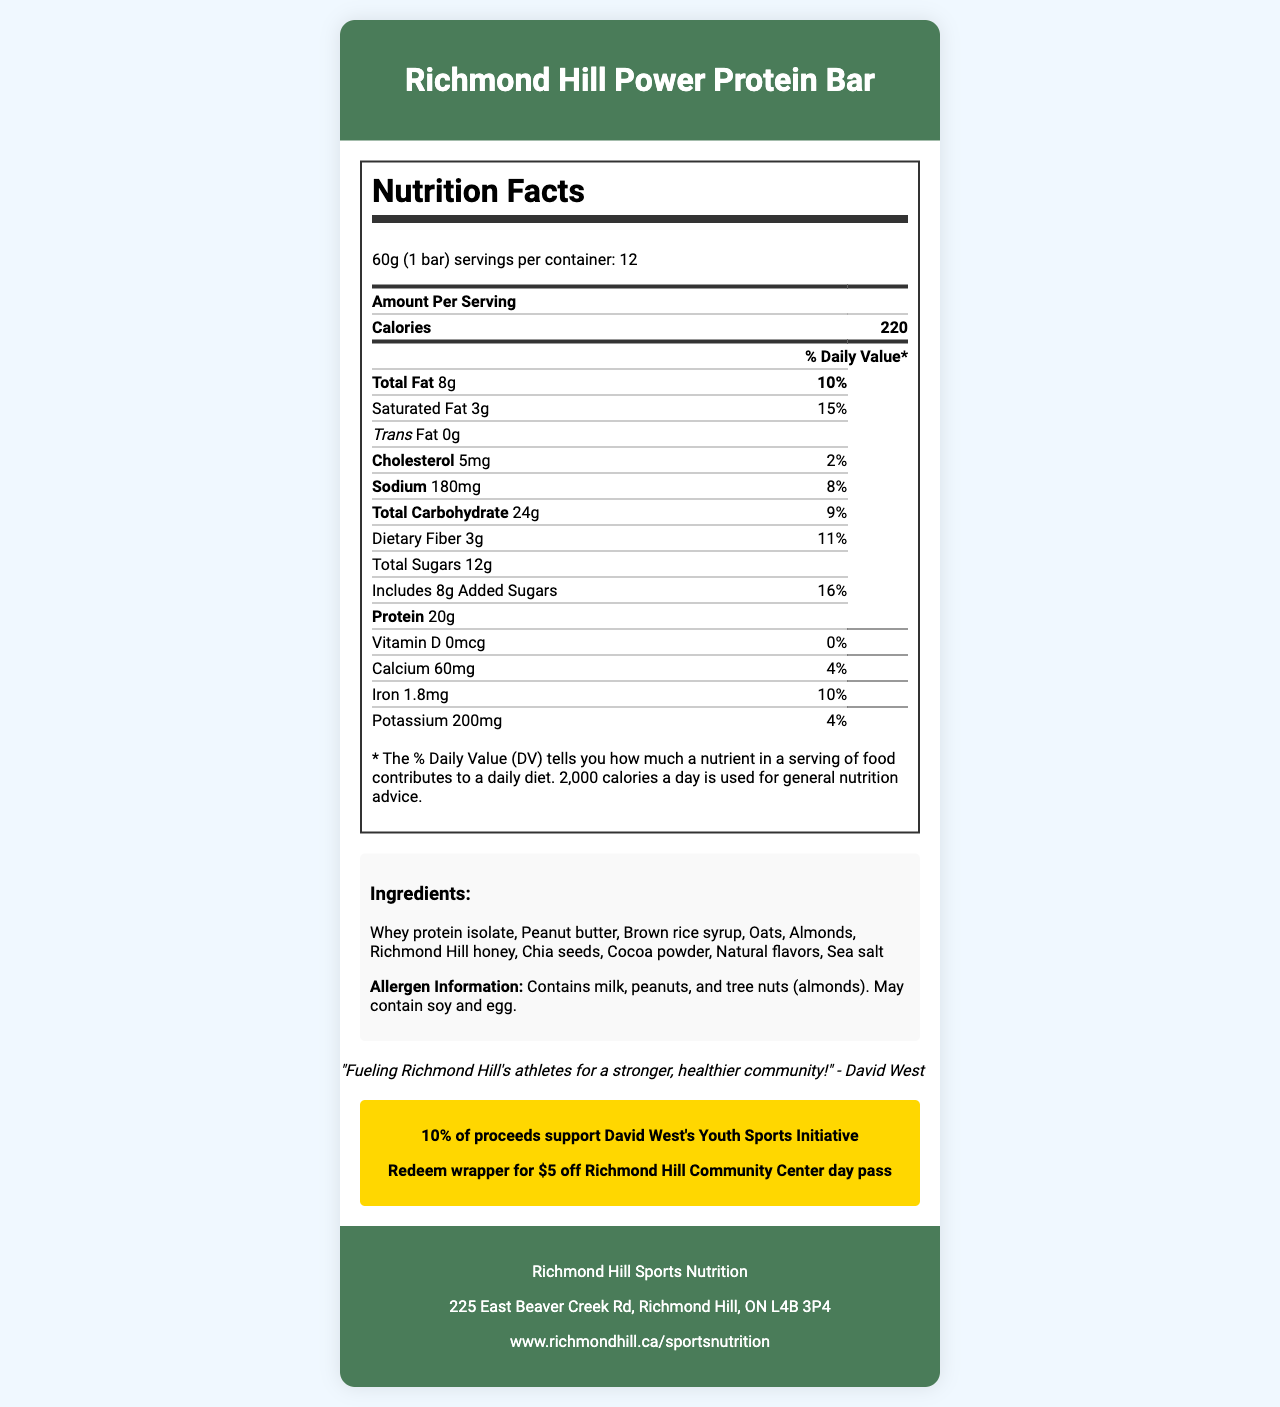what is the serving size for one Richmond Hill Power Protein Bar? The serving size is mentioned at the top of the Nutrition Facts section: "Serving size 60g (1 bar)."
Answer: 60g (1 bar) how many servings are there per container? The number of servings per container is specified as "Servings per container: 12" at the top of the Nutrition Facts section.
Answer: 12 how many calories are present in one serving of the protein bar? The Nutrition Facts section lists "Calories" with the value "220" for one serving.
Answer: 220 what is the percentage of Daily Value for saturated fat per serving? The table in the Nutrition Facts section mentions "Saturated Fat 3g" followed by "15%" under the % Daily Value column.
Answer: 15% how many grams of protein does one bar contain? The amount of protein per serving is listed in the table as "Protein 20g."
Answer: 20g how much iron does one Richmond Hill Power Protein Bar provide? A. 0.5mg B. 1.8mg C. 3mg The Nutrition Facts section lists "Iron 1.8mg" which corresponds to option B.
Answer: B how many milligrams of sodium does the Richmond Hill Power Protein Bar have per serving? The amount of sodium per serving is mentioned as "Sodium 180mg" in the table.
Answer: 180mg which of the following ingredients is NOT found in the Richmond Hill Power Protein Bar? A. Whey protein isolate B. Peanut butter C. Soy lecithin D. Chia seeds The ingredients list includes "Whey protein isolate, Peanut butter," and "Chia seeds," but not "Soy lecithin."
Answer: C true or false: the protein bar contains trans fat. The document lists "Trans Fat 0g" indicating that the bar does not contain trans fat.
Answer: False summarize the main idea of the Richmond Hill Power Protein Bar’s Nutrition Facts document. The document includes a nutritional breakdown of the protein bar, ingredient list, allergen warnings, manufacturer details, promotional information for sports programs, and a quote from David West, encouraging community health and fitness.
Answer: The document provides detailed nutrition information for the Richmond Hill Power Protein Bar, including serving size, calories, macronutrients, vitamins, and minerals. It highlights the ingredients and allergen information, promotes Richmond Hill sports programs with a quote from David West, and offers a discount at the Richmond Hill Community Center. how much dietary fiber does one serving of the protein bar contain? The Nutrition Facts section lists "Dietary Fiber 3g" in the table.
Answer: 3g does the protein bar contain any added sugars? The table lists "Includes 8g Added Sugars" under the Total Sugars section, indicating that the bar contains added sugars.
Answer: Yes what is the website for Richmond Hill Sports Nutrition? The footer of the document lists the website as "www.richmondhill.ca/sportsnutrition."
Answer: www.richmondhill.ca/sportsnutrition how much cholesterol is in one serving? The amount of cholesterol per serving is indicated as "Cholesterol 5mg" in the Nutrition Facts table.
Answer: 5mg what is David West’s role in promoting this protein bar? The document includes a quote from David West saying "Fueling Richmond Hill's athletes for a stronger, healthier community!"
Answer: Fueling Richmond Hill's athletes for a stronger, healthier community. where is the Richmond Hill Sports Nutrition manufacturer located? The manufacturer's address is provided in the footer of the document.
Answer: 225 East Beaver Creek Rd, Richmond Hill, ON L4B 3P4 does this protein bar support any community initiatives? If so, what is supported? The promotional section in the document states, "10% of proceeds support David West's Youth Sports Initiative."
Answer: Yes, it supports David West's Youth Sports Initiative. what is the recommended daily caloric intake the % Daily Value is based on? The document notes, "The % Daily Value (DV) tells you how much a nutrient in a serving of food contributes to a daily diet. 2,000 calories a day is used for general nutrition advice."
Answer: 2,000 calories what flavors are included in the Richmond Hill Power Protein Bar? The ingredients list "Natural flavors" among the other ingredients.
Answer: Natural flavors how much potassium is in the protein bar? The amount of potassium per serving is listed as "Potassium 200mg" in the table.
Answer: 200mg what is the main source of sweetness in the Richmond Hill Power Protein Bar? The ingredients list includes "Brown rice syrup" and "Richmond Hill honey" as sources of sweetness.
Answer: Brown rice syrup and Richmond Hill honey are eggs present in the protein bar? The allergen information states "May contain soy and egg," which means it's not confirmed whether eggs are present in every bar.
Answer: Not enough information 